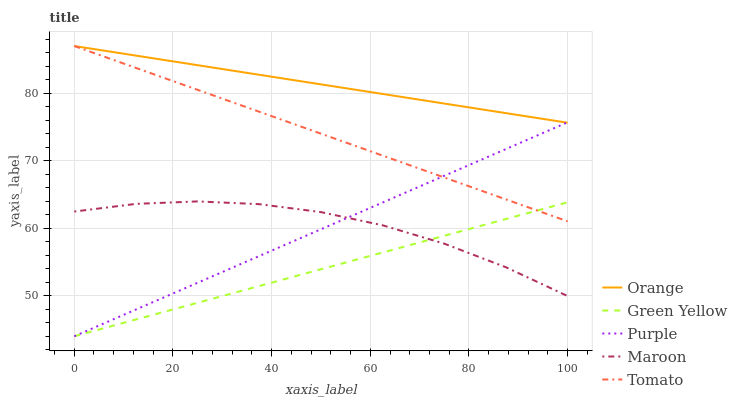Does Purple have the minimum area under the curve?
Answer yes or no. No. Does Purple have the maximum area under the curve?
Answer yes or no. No. Is Purple the smoothest?
Answer yes or no. No. Is Purple the roughest?
Answer yes or no. No. Does Tomato have the lowest value?
Answer yes or no. No. Does Purple have the highest value?
Answer yes or no. No. Is Maroon less than Tomato?
Answer yes or no. Yes. Is Tomato greater than Maroon?
Answer yes or no. Yes. Does Maroon intersect Tomato?
Answer yes or no. No. 